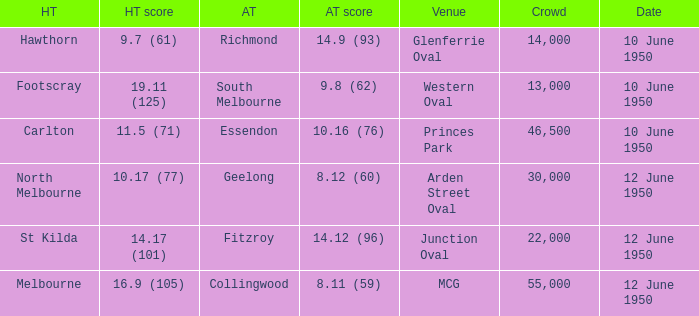What was the crowd when Melbourne was the home team? 55000.0. 